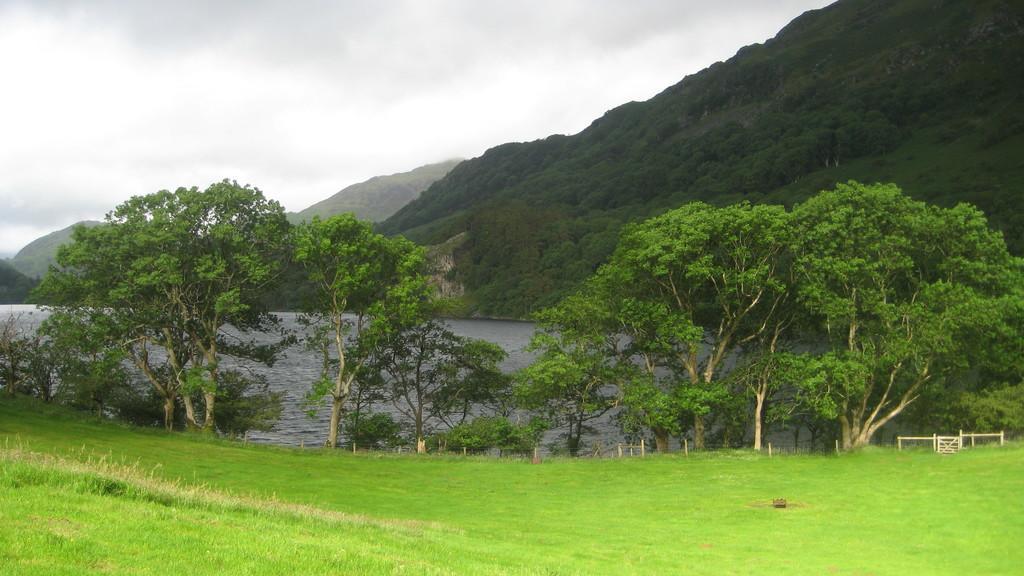In one or two sentences, can you explain what this image depicts? This picture might be taken from outside of the city. In this image, on the right side, we can see some trees, plants and rocks. On the left side, we can also see some trees, plants. In the background, we can see some rocks. On the top, we can see a sky which is cloudy, at the bottom there is a water in a lake and a grass. 